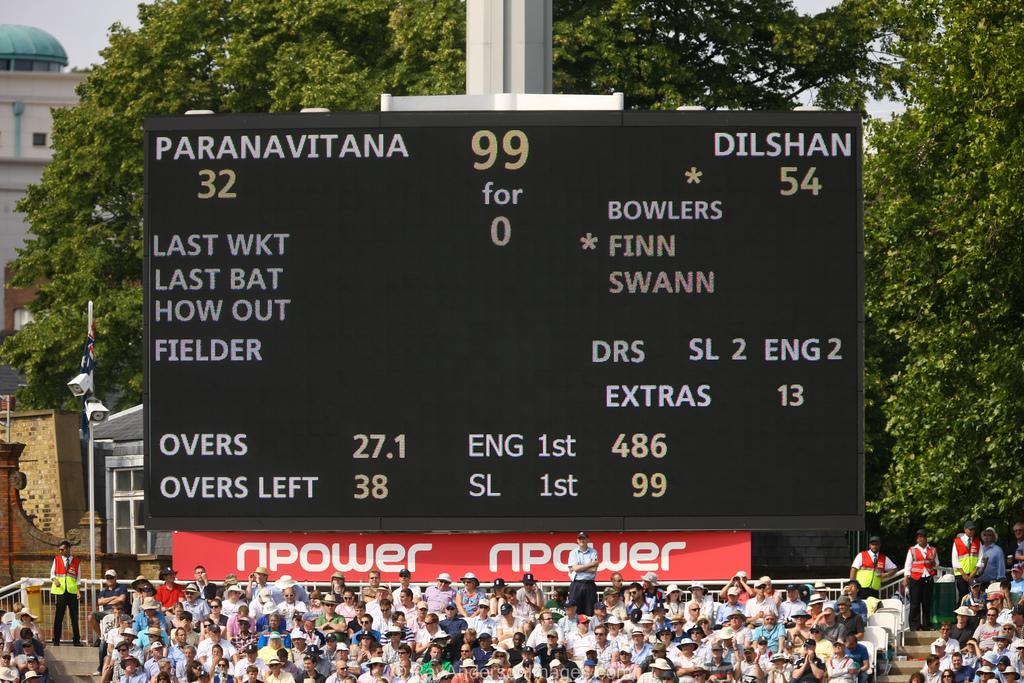Who can win ?
Make the answer very short. Dilshan. 